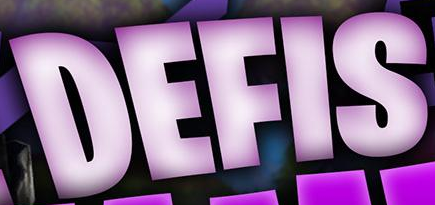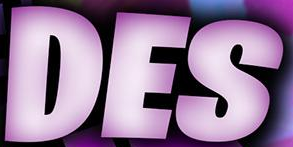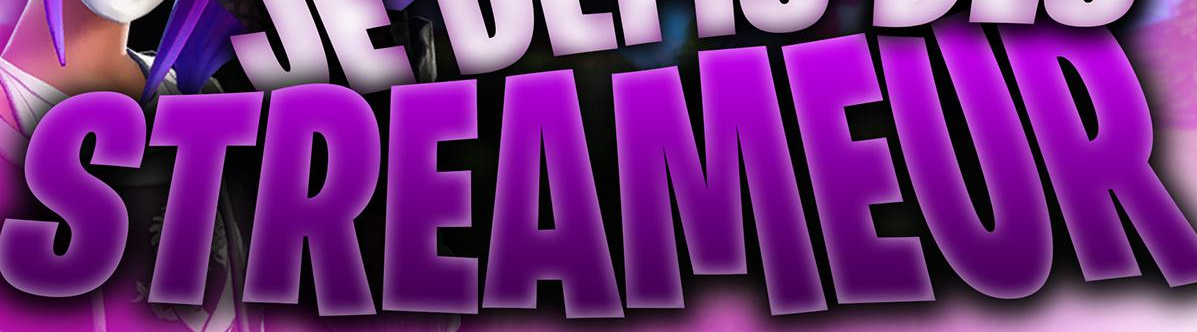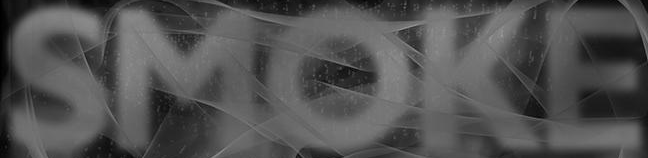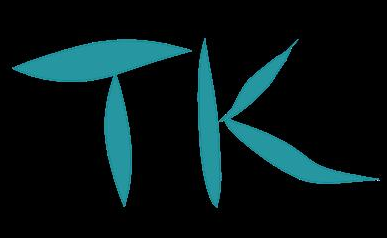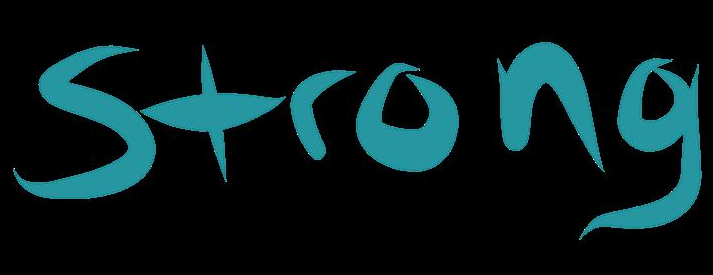What words can you see in these images in sequence, separated by a semicolon? DEFIS; DES; STREAMEUR; SMOKE; TK; Strong 